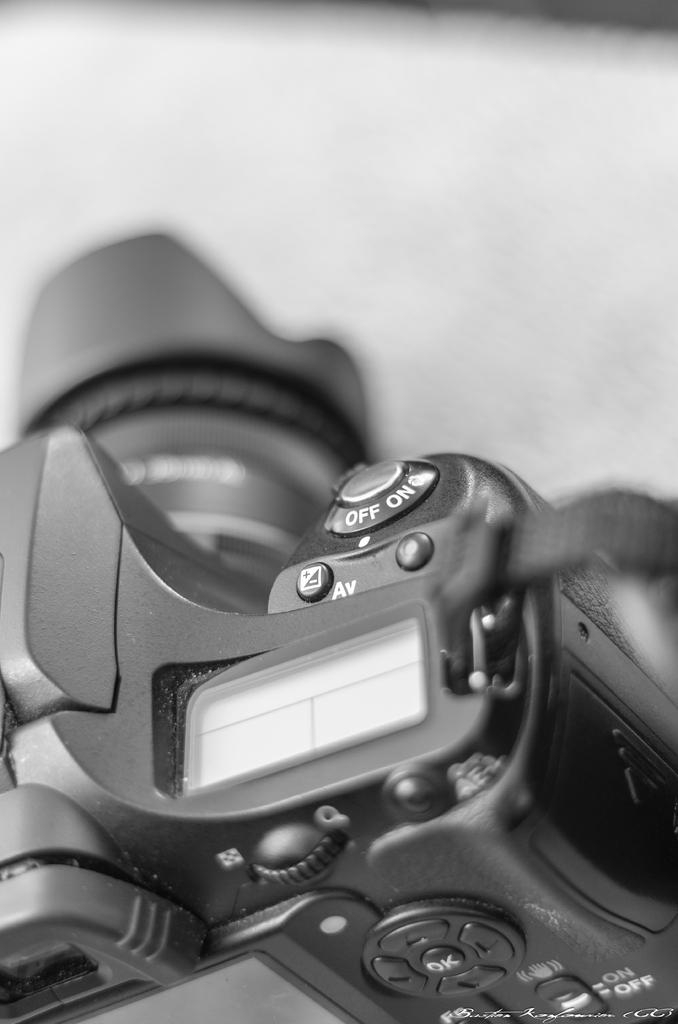What object is located at the bottom of the image? There is a camera at the bottom of the image. What piece of furniture is at the top of the image? There is a table at the top of the image. How does the camera help the crayon in the image? There is no crayon present in the image, and therefore the camera cannot help it. 